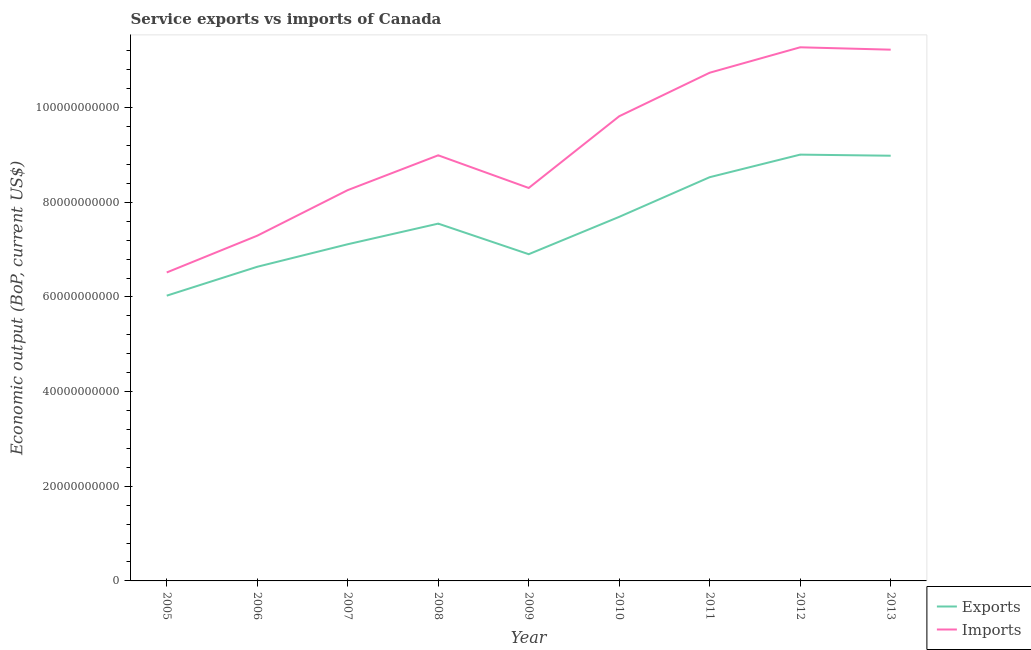Does the line corresponding to amount of service imports intersect with the line corresponding to amount of service exports?
Your answer should be compact. No. Is the number of lines equal to the number of legend labels?
Make the answer very short. Yes. What is the amount of service imports in 2007?
Keep it short and to the point. 8.26e+1. Across all years, what is the maximum amount of service exports?
Your answer should be compact. 9.01e+1. Across all years, what is the minimum amount of service exports?
Make the answer very short. 6.03e+1. In which year was the amount of service imports minimum?
Provide a succinct answer. 2005. What is the total amount of service exports in the graph?
Your response must be concise. 6.84e+11. What is the difference between the amount of service exports in 2011 and that in 2012?
Provide a short and direct response. -4.77e+09. What is the difference between the amount of service imports in 2008 and the amount of service exports in 2005?
Keep it short and to the point. 2.97e+1. What is the average amount of service imports per year?
Provide a succinct answer. 9.16e+1. In the year 2013, what is the difference between the amount of service exports and amount of service imports?
Your response must be concise. -2.24e+1. In how many years, is the amount of service imports greater than 36000000000 US$?
Your answer should be compact. 9. What is the ratio of the amount of service exports in 2010 to that in 2011?
Keep it short and to the point. 0.9. Is the difference between the amount of service imports in 2005 and 2010 greater than the difference between the amount of service exports in 2005 and 2010?
Your response must be concise. No. What is the difference between the highest and the second highest amount of service imports?
Give a very brief answer. 5.01e+08. What is the difference between the highest and the lowest amount of service imports?
Give a very brief answer. 4.76e+1. Is the amount of service exports strictly greater than the amount of service imports over the years?
Provide a short and direct response. No. How many lines are there?
Provide a succinct answer. 2. How many years are there in the graph?
Provide a succinct answer. 9. Does the graph contain any zero values?
Your response must be concise. No. What is the title of the graph?
Keep it short and to the point. Service exports vs imports of Canada. What is the label or title of the X-axis?
Your answer should be very brief. Year. What is the label or title of the Y-axis?
Keep it short and to the point. Economic output (BoP, current US$). What is the Economic output (BoP, current US$) of Exports in 2005?
Your answer should be very brief. 6.03e+1. What is the Economic output (BoP, current US$) in Imports in 2005?
Your response must be concise. 6.52e+1. What is the Economic output (BoP, current US$) of Exports in 2006?
Provide a short and direct response. 6.64e+1. What is the Economic output (BoP, current US$) of Imports in 2006?
Give a very brief answer. 7.29e+1. What is the Economic output (BoP, current US$) of Exports in 2007?
Keep it short and to the point. 7.11e+1. What is the Economic output (BoP, current US$) in Imports in 2007?
Your response must be concise. 8.26e+1. What is the Economic output (BoP, current US$) in Exports in 2008?
Your answer should be compact. 7.55e+1. What is the Economic output (BoP, current US$) of Imports in 2008?
Ensure brevity in your answer.  8.99e+1. What is the Economic output (BoP, current US$) of Exports in 2009?
Ensure brevity in your answer.  6.90e+1. What is the Economic output (BoP, current US$) in Imports in 2009?
Make the answer very short. 8.30e+1. What is the Economic output (BoP, current US$) of Exports in 2010?
Give a very brief answer. 7.69e+1. What is the Economic output (BoP, current US$) in Imports in 2010?
Your response must be concise. 9.82e+1. What is the Economic output (BoP, current US$) of Exports in 2011?
Offer a very short reply. 8.53e+1. What is the Economic output (BoP, current US$) of Imports in 2011?
Keep it short and to the point. 1.07e+11. What is the Economic output (BoP, current US$) of Exports in 2012?
Ensure brevity in your answer.  9.01e+1. What is the Economic output (BoP, current US$) of Imports in 2012?
Your answer should be compact. 1.13e+11. What is the Economic output (BoP, current US$) of Exports in 2013?
Give a very brief answer. 8.98e+1. What is the Economic output (BoP, current US$) in Imports in 2013?
Offer a very short reply. 1.12e+11. Across all years, what is the maximum Economic output (BoP, current US$) of Exports?
Your answer should be very brief. 9.01e+1. Across all years, what is the maximum Economic output (BoP, current US$) in Imports?
Give a very brief answer. 1.13e+11. Across all years, what is the minimum Economic output (BoP, current US$) in Exports?
Your answer should be compact. 6.03e+1. Across all years, what is the minimum Economic output (BoP, current US$) of Imports?
Keep it short and to the point. 6.52e+1. What is the total Economic output (BoP, current US$) in Exports in the graph?
Your answer should be compact. 6.84e+11. What is the total Economic output (BoP, current US$) of Imports in the graph?
Your answer should be compact. 8.24e+11. What is the difference between the Economic output (BoP, current US$) of Exports in 2005 and that in 2006?
Ensure brevity in your answer.  -6.10e+09. What is the difference between the Economic output (BoP, current US$) of Imports in 2005 and that in 2006?
Offer a very short reply. -7.77e+09. What is the difference between the Economic output (BoP, current US$) in Exports in 2005 and that in 2007?
Offer a very short reply. -1.09e+1. What is the difference between the Economic output (BoP, current US$) in Imports in 2005 and that in 2007?
Your response must be concise. -1.74e+1. What is the difference between the Economic output (BoP, current US$) of Exports in 2005 and that in 2008?
Give a very brief answer. -1.52e+1. What is the difference between the Economic output (BoP, current US$) of Imports in 2005 and that in 2008?
Give a very brief answer. -2.48e+1. What is the difference between the Economic output (BoP, current US$) in Exports in 2005 and that in 2009?
Your answer should be very brief. -8.76e+09. What is the difference between the Economic output (BoP, current US$) of Imports in 2005 and that in 2009?
Provide a succinct answer. -1.79e+1. What is the difference between the Economic output (BoP, current US$) in Exports in 2005 and that in 2010?
Offer a very short reply. -1.67e+1. What is the difference between the Economic output (BoP, current US$) of Imports in 2005 and that in 2010?
Your answer should be compact. -3.30e+1. What is the difference between the Economic output (BoP, current US$) of Exports in 2005 and that in 2011?
Offer a very short reply. -2.50e+1. What is the difference between the Economic output (BoP, current US$) of Imports in 2005 and that in 2011?
Provide a short and direct response. -4.22e+1. What is the difference between the Economic output (BoP, current US$) in Exports in 2005 and that in 2012?
Give a very brief answer. -2.98e+1. What is the difference between the Economic output (BoP, current US$) of Imports in 2005 and that in 2012?
Provide a short and direct response. -4.76e+1. What is the difference between the Economic output (BoP, current US$) in Exports in 2005 and that in 2013?
Make the answer very short. -2.96e+1. What is the difference between the Economic output (BoP, current US$) of Imports in 2005 and that in 2013?
Provide a succinct answer. -4.71e+1. What is the difference between the Economic output (BoP, current US$) in Exports in 2006 and that in 2007?
Give a very brief answer. -4.76e+09. What is the difference between the Economic output (BoP, current US$) in Imports in 2006 and that in 2007?
Make the answer very short. -9.63e+09. What is the difference between the Economic output (BoP, current US$) in Exports in 2006 and that in 2008?
Offer a very short reply. -9.12e+09. What is the difference between the Economic output (BoP, current US$) of Imports in 2006 and that in 2008?
Provide a succinct answer. -1.70e+1. What is the difference between the Economic output (BoP, current US$) of Exports in 2006 and that in 2009?
Give a very brief answer. -2.66e+09. What is the difference between the Economic output (BoP, current US$) of Imports in 2006 and that in 2009?
Keep it short and to the point. -1.01e+1. What is the difference between the Economic output (BoP, current US$) in Exports in 2006 and that in 2010?
Make the answer very short. -1.05e+1. What is the difference between the Economic output (BoP, current US$) of Imports in 2006 and that in 2010?
Your answer should be compact. -2.52e+1. What is the difference between the Economic output (BoP, current US$) in Exports in 2006 and that in 2011?
Provide a succinct answer. -1.89e+1. What is the difference between the Economic output (BoP, current US$) in Imports in 2006 and that in 2011?
Your response must be concise. -3.44e+1. What is the difference between the Economic output (BoP, current US$) in Exports in 2006 and that in 2012?
Offer a terse response. -2.37e+1. What is the difference between the Economic output (BoP, current US$) in Imports in 2006 and that in 2012?
Give a very brief answer. -3.98e+1. What is the difference between the Economic output (BoP, current US$) of Exports in 2006 and that in 2013?
Your answer should be very brief. -2.35e+1. What is the difference between the Economic output (BoP, current US$) of Imports in 2006 and that in 2013?
Your answer should be compact. -3.93e+1. What is the difference between the Economic output (BoP, current US$) in Exports in 2007 and that in 2008?
Offer a very short reply. -4.36e+09. What is the difference between the Economic output (BoP, current US$) in Imports in 2007 and that in 2008?
Make the answer very short. -7.35e+09. What is the difference between the Economic output (BoP, current US$) in Exports in 2007 and that in 2009?
Your answer should be very brief. 2.10e+09. What is the difference between the Economic output (BoP, current US$) in Imports in 2007 and that in 2009?
Your response must be concise. -4.55e+08. What is the difference between the Economic output (BoP, current US$) of Exports in 2007 and that in 2010?
Your answer should be very brief. -5.79e+09. What is the difference between the Economic output (BoP, current US$) in Imports in 2007 and that in 2010?
Offer a very short reply. -1.56e+1. What is the difference between the Economic output (BoP, current US$) of Exports in 2007 and that in 2011?
Offer a terse response. -1.42e+1. What is the difference between the Economic output (BoP, current US$) of Imports in 2007 and that in 2011?
Offer a very short reply. -2.48e+1. What is the difference between the Economic output (BoP, current US$) in Exports in 2007 and that in 2012?
Make the answer very short. -1.89e+1. What is the difference between the Economic output (BoP, current US$) in Imports in 2007 and that in 2012?
Ensure brevity in your answer.  -3.02e+1. What is the difference between the Economic output (BoP, current US$) in Exports in 2007 and that in 2013?
Your response must be concise. -1.87e+1. What is the difference between the Economic output (BoP, current US$) in Imports in 2007 and that in 2013?
Your answer should be compact. -2.97e+1. What is the difference between the Economic output (BoP, current US$) of Exports in 2008 and that in 2009?
Keep it short and to the point. 6.46e+09. What is the difference between the Economic output (BoP, current US$) in Imports in 2008 and that in 2009?
Give a very brief answer. 6.90e+09. What is the difference between the Economic output (BoP, current US$) in Exports in 2008 and that in 2010?
Offer a terse response. -1.43e+09. What is the difference between the Economic output (BoP, current US$) in Imports in 2008 and that in 2010?
Give a very brief answer. -8.25e+09. What is the difference between the Economic output (BoP, current US$) of Exports in 2008 and that in 2011?
Ensure brevity in your answer.  -9.81e+09. What is the difference between the Economic output (BoP, current US$) of Imports in 2008 and that in 2011?
Your answer should be compact. -1.75e+1. What is the difference between the Economic output (BoP, current US$) of Exports in 2008 and that in 2012?
Ensure brevity in your answer.  -1.46e+1. What is the difference between the Economic output (BoP, current US$) of Imports in 2008 and that in 2012?
Make the answer very short. -2.28e+1. What is the difference between the Economic output (BoP, current US$) in Exports in 2008 and that in 2013?
Ensure brevity in your answer.  -1.43e+1. What is the difference between the Economic output (BoP, current US$) in Imports in 2008 and that in 2013?
Offer a terse response. -2.23e+1. What is the difference between the Economic output (BoP, current US$) of Exports in 2009 and that in 2010?
Your response must be concise. -7.89e+09. What is the difference between the Economic output (BoP, current US$) of Imports in 2009 and that in 2010?
Provide a short and direct response. -1.52e+1. What is the difference between the Economic output (BoP, current US$) of Exports in 2009 and that in 2011?
Give a very brief answer. -1.63e+1. What is the difference between the Economic output (BoP, current US$) of Imports in 2009 and that in 2011?
Provide a succinct answer. -2.44e+1. What is the difference between the Economic output (BoP, current US$) in Exports in 2009 and that in 2012?
Keep it short and to the point. -2.10e+1. What is the difference between the Economic output (BoP, current US$) of Imports in 2009 and that in 2012?
Provide a short and direct response. -2.97e+1. What is the difference between the Economic output (BoP, current US$) in Exports in 2009 and that in 2013?
Offer a terse response. -2.08e+1. What is the difference between the Economic output (BoP, current US$) in Imports in 2009 and that in 2013?
Provide a short and direct response. -2.92e+1. What is the difference between the Economic output (BoP, current US$) in Exports in 2010 and that in 2011?
Your response must be concise. -8.38e+09. What is the difference between the Economic output (BoP, current US$) of Imports in 2010 and that in 2011?
Keep it short and to the point. -9.20e+09. What is the difference between the Economic output (BoP, current US$) in Exports in 2010 and that in 2012?
Ensure brevity in your answer.  -1.32e+1. What is the difference between the Economic output (BoP, current US$) of Imports in 2010 and that in 2012?
Offer a terse response. -1.46e+1. What is the difference between the Economic output (BoP, current US$) in Exports in 2010 and that in 2013?
Provide a succinct answer. -1.29e+1. What is the difference between the Economic output (BoP, current US$) of Imports in 2010 and that in 2013?
Make the answer very short. -1.41e+1. What is the difference between the Economic output (BoP, current US$) in Exports in 2011 and that in 2012?
Offer a very short reply. -4.77e+09. What is the difference between the Economic output (BoP, current US$) in Imports in 2011 and that in 2012?
Provide a short and direct response. -5.37e+09. What is the difference between the Economic output (BoP, current US$) of Exports in 2011 and that in 2013?
Provide a short and direct response. -4.54e+09. What is the difference between the Economic output (BoP, current US$) in Imports in 2011 and that in 2013?
Ensure brevity in your answer.  -4.87e+09. What is the difference between the Economic output (BoP, current US$) in Exports in 2012 and that in 2013?
Provide a short and direct response. 2.33e+08. What is the difference between the Economic output (BoP, current US$) in Imports in 2012 and that in 2013?
Provide a short and direct response. 5.01e+08. What is the difference between the Economic output (BoP, current US$) in Exports in 2005 and the Economic output (BoP, current US$) in Imports in 2006?
Make the answer very short. -1.27e+1. What is the difference between the Economic output (BoP, current US$) of Exports in 2005 and the Economic output (BoP, current US$) of Imports in 2007?
Ensure brevity in your answer.  -2.23e+1. What is the difference between the Economic output (BoP, current US$) of Exports in 2005 and the Economic output (BoP, current US$) of Imports in 2008?
Offer a terse response. -2.97e+1. What is the difference between the Economic output (BoP, current US$) in Exports in 2005 and the Economic output (BoP, current US$) in Imports in 2009?
Offer a very short reply. -2.28e+1. What is the difference between the Economic output (BoP, current US$) in Exports in 2005 and the Economic output (BoP, current US$) in Imports in 2010?
Make the answer very short. -3.79e+1. What is the difference between the Economic output (BoP, current US$) of Exports in 2005 and the Economic output (BoP, current US$) of Imports in 2011?
Make the answer very short. -4.71e+1. What is the difference between the Economic output (BoP, current US$) in Exports in 2005 and the Economic output (BoP, current US$) in Imports in 2012?
Ensure brevity in your answer.  -5.25e+1. What is the difference between the Economic output (BoP, current US$) of Exports in 2005 and the Economic output (BoP, current US$) of Imports in 2013?
Offer a terse response. -5.20e+1. What is the difference between the Economic output (BoP, current US$) of Exports in 2006 and the Economic output (BoP, current US$) of Imports in 2007?
Your response must be concise. -1.62e+1. What is the difference between the Economic output (BoP, current US$) in Exports in 2006 and the Economic output (BoP, current US$) in Imports in 2008?
Keep it short and to the point. -2.36e+1. What is the difference between the Economic output (BoP, current US$) in Exports in 2006 and the Economic output (BoP, current US$) in Imports in 2009?
Your answer should be very brief. -1.67e+1. What is the difference between the Economic output (BoP, current US$) in Exports in 2006 and the Economic output (BoP, current US$) in Imports in 2010?
Your answer should be very brief. -3.18e+1. What is the difference between the Economic output (BoP, current US$) of Exports in 2006 and the Economic output (BoP, current US$) of Imports in 2011?
Give a very brief answer. -4.10e+1. What is the difference between the Economic output (BoP, current US$) in Exports in 2006 and the Economic output (BoP, current US$) in Imports in 2012?
Make the answer very short. -4.64e+1. What is the difference between the Economic output (BoP, current US$) in Exports in 2006 and the Economic output (BoP, current US$) in Imports in 2013?
Your response must be concise. -4.59e+1. What is the difference between the Economic output (BoP, current US$) of Exports in 2007 and the Economic output (BoP, current US$) of Imports in 2008?
Keep it short and to the point. -1.88e+1. What is the difference between the Economic output (BoP, current US$) of Exports in 2007 and the Economic output (BoP, current US$) of Imports in 2009?
Give a very brief answer. -1.19e+1. What is the difference between the Economic output (BoP, current US$) in Exports in 2007 and the Economic output (BoP, current US$) in Imports in 2010?
Keep it short and to the point. -2.70e+1. What is the difference between the Economic output (BoP, current US$) in Exports in 2007 and the Economic output (BoP, current US$) in Imports in 2011?
Offer a terse response. -3.62e+1. What is the difference between the Economic output (BoP, current US$) in Exports in 2007 and the Economic output (BoP, current US$) in Imports in 2012?
Make the answer very short. -4.16e+1. What is the difference between the Economic output (BoP, current US$) in Exports in 2007 and the Economic output (BoP, current US$) in Imports in 2013?
Your response must be concise. -4.11e+1. What is the difference between the Economic output (BoP, current US$) in Exports in 2008 and the Economic output (BoP, current US$) in Imports in 2009?
Ensure brevity in your answer.  -7.53e+09. What is the difference between the Economic output (BoP, current US$) of Exports in 2008 and the Economic output (BoP, current US$) of Imports in 2010?
Make the answer very short. -2.27e+1. What is the difference between the Economic output (BoP, current US$) in Exports in 2008 and the Economic output (BoP, current US$) in Imports in 2011?
Give a very brief answer. -3.19e+1. What is the difference between the Economic output (BoP, current US$) of Exports in 2008 and the Economic output (BoP, current US$) of Imports in 2012?
Your response must be concise. -3.73e+1. What is the difference between the Economic output (BoP, current US$) of Exports in 2008 and the Economic output (BoP, current US$) of Imports in 2013?
Your response must be concise. -3.68e+1. What is the difference between the Economic output (BoP, current US$) in Exports in 2009 and the Economic output (BoP, current US$) in Imports in 2010?
Provide a succinct answer. -2.91e+1. What is the difference between the Economic output (BoP, current US$) of Exports in 2009 and the Economic output (BoP, current US$) of Imports in 2011?
Provide a succinct answer. -3.83e+1. What is the difference between the Economic output (BoP, current US$) of Exports in 2009 and the Economic output (BoP, current US$) of Imports in 2012?
Give a very brief answer. -4.37e+1. What is the difference between the Economic output (BoP, current US$) of Exports in 2009 and the Economic output (BoP, current US$) of Imports in 2013?
Your answer should be very brief. -4.32e+1. What is the difference between the Economic output (BoP, current US$) of Exports in 2010 and the Economic output (BoP, current US$) of Imports in 2011?
Your answer should be very brief. -3.05e+1. What is the difference between the Economic output (BoP, current US$) in Exports in 2010 and the Economic output (BoP, current US$) in Imports in 2012?
Make the answer very short. -3.58e+1. What is the difference between the Economic output (BoP, current US$) in Exports in 2010 and the Economic output (BoP, current US$) in Imports in 2013?
Offer a terse response. -3.53e+1. What is the difference between the Economic output (BoP, current US$) in Exports in 2011 and the Economic output (BoP, current US$) in Imports in 2012?
Offer a terse response. -2.74e+1. What is the difference between the Economic output (BoP, current US$) of Exports in 2011 and the Economic output (BoP, current US$) of Imports in 2013?
Ensure brevity in your answer.  -2.69e+1. What is the difference between the Economic output (BoP, current US$) in Exports in 2012 and the Economic output (BoP, current US$) in Imports in 2013?
Your answer should be compact. -2.22e+1. What is the average Economic output (BoP, current US$) of Exports per year?
Provide a short and direct response. 7.61e+1. What is the average Economic output (BoP, current US$) of Imports per year?
Your answer should be compact. 9.16e+1. In the year 2005, what is the difference between the Economic output (BoP, current US$) in Exports and Economic output (BoP, current US$) in Imports?
Offer a very short reply. -4.90e+09. In the year 2006, what is the difference between the Economic output (BoP, current US$) in Exports and Economic output (BoP, current US$) in Imports?
Ensure brevity in your answer.  -6.57e+09. In the year 2007, what is the difference between the Economic output (BoP, current US$) of Exports and Economic output (BoP, current US$) of Imports?
Offer a very short reply. -1.14e+1. In the year 2008, what is the difference between the Economic output (BoP, current US$) of Exports and Economic output (BoP, current US$) of Imports?
Provide a succinct answer. -1.44e+1. In the year 2009, what is the difference between the Economic output (BoP, current US$) in Exports and Economic output (BoP, current US$) in Imports?
Make the answer very short. -1.40e+1. In the year 2010, what is the difference between the Economic output (BoP, current US$) in Exports and Economic output (BoP, current US$) in Imports?
Keep it short and to the point. -2.13e+1. In the year 2011, what is the difference between the Economic output (BoP, current US$) of Exports and Economic output (BoP, current US$) of Imports?
Your answer should be very brief. -2.21e+1. In the year 2012, what is the difference between the Economic output (BoP, current US$) in Exports and Economic output (BoP, current US$) in Imports?
Provide a succinct answer. -2.27e+1. In the year 2013, what is the difference between the Economic output (BoP, current US$) in Exports and Economic output (BoP, current US$) in Imports?
Your answer should be very brief. -2.24e+1. What is the ratio of the Economic output (BoP, current US$) of Exports in 2005 to that in 2006?
Your answer should be compact. 0.91. What is the ratio of the Economic output (BoP, current US$) of Imports in 2005 to that in 2006?
Provide a short and direct response. 0.89. What is the ratio of the Economic output (BoP, current US$) in Exports in 2005 to that in 2007?
Your response must be concise. 0.85. What is the ratio of the Economic output (BoP, current US$) in Imports in 2005 to that in 2007?
Your response must be concise. 0.79. What is the ratio of the Economic output (BoP, current US$) of Exports in 2005 to that in 2008?
Ensure brevity in your answer.  0.8. What is the ratio of the Economic output (BoP, current US$) in Imports in 2005 to that in 2008?
Give a very brief answer. 0.72. What is the ratio of the Economic output (BoP, current US$) of Exports in 2005 to that in 2009?
Give a very brief answer. 0.87. What is the ratio of the Economic output (BoP, current US$) of Imports in 2005 to that in 2009?
Ensure brevity in your answer.  0.79. What is the ratio of the Economic output (BoP, current US$) in Exports in 2005 to that in 2010?
Keep it short and to the point. 0.78. What is the ratio of the Economic output (BoP, current US$) in Imports in 2005 to that in 2010?
Ensure brevity in your answer.  0.66. What is the ratio of the Economic output (BoP, current US$) of Exports in 2005 to that in 2011?
Provide a short and direct response. 0.71. What is the ratio of the Economic output (BoP, current US$) of Imports in 2005 to that in 2011?
Provide a short and direct response. 0.61. What is the ratio of the Economic output (BoP, current US$) of Exports in 2005 to that in 2012?
Your answer should be very brief. 0.67. What is the ratio of the Economic output (BoP, current US$) of Imports in 2005 to that in 2012?
Your answer should be very brief. 0.58. What is the ratio of the Economic output (BoP, current US$) in Exports in 2005 to that in 2013?
Offer a terse response. 0.67. What is the ratio of the Economic output (BoP, current US$) in Imports in 2005 to that in 2013?
Offer a terse response. 0.58. What is the ratio of the Economic output (BoP, current US$) of Exports in 2006 to that in 2007?
Make the answer very short. 0.93. What is the ratio of the Economic output (BoP, current US$) in Imports in 2006 to that in 2007?
Your answer should be very brief. 0.88. What is the ratio of the Economic output (BoP, current US$) of Exports in 2006 to that in 2008?
Your answer should be compact. 0.88. What is the ratio of the Economic output (BoP, current US$) of Imports in 2006 to that in 2008?
Ensure brevity in your answer.  0.81. What is the ratio of the Economic output (BoP, current US$) of Exports in 2006 to that in 2009?
Offer a terse response. 0.96. What is the ratio of the Economic output (BoP, current US$) in Imports in 2006 to that in 2009?
Offer a very short reply. 0.88. What is the ratio of the Economic output (BoP, current US$) in Exports in 2006 to that in 2010?
Give a very brief answer. 0.86. What is the ratio of the Economic output (BoP, current US$) in Imports in 2006 to that in 2010?
Provide a succinct answer. 0.74. What is the ratio of the Economic output (BoP, current US$) in Exports in 2006 to that in 2011?
Ensure brevity in your answer.  0.78. What is the ratio of the Economic output (BoP, current US$) of Imports in 2006 to that in 2011?
Ensure brevity in your answer.  0.68. What is the ratio of the Economic output (BoP, current US$) of Exports in 2006 to that in 2012?
Give a very brief answer. 0.74. What is the ratio of the Economic output (BoP, current US$) of Imports in 2006 to that in 2012?
Provide a succinct answer. 0.65. What is the ratio of the Economic output (BoP, current US$) of Exports in 2006 to that in 2013?
Give a very brief answer. 0.74. What is the ratio of the Economic output (BoP, current US$) of Imports in 2006 to that in 2013?
Your response must be concise. 0.65. What is the ratio of the Economic output (BoP, current US$) of Exports in 2007 to that in 2008?
Offer a very short reply. 0.94. What is the ratio of the Economic output (BoP, current US$) in Imports in 2007 to that in 2008?
Provide a short and direct response. 0.92. What is the ratio of the Economic output (BoP, current US$) of Exports in 2007 to that in 2009?
Your answer should be compact. 1.03. What is the ratio of the Economic output (BoP, current US$) of Imports in 2007 to that in 2009?
Provide a succinct answer. 0.99. What is the ratio of the Economic output (BoP, current US$) of Exports in 2007 to that in 2010?
Ensure brevity in your answer.  0.92. What is the ratio of the Economic output (BoP, current US$) in Imports in 2007 to that in 2010?
Offer a very short reply. 0.84. What is the ratio of the Economic output (BoP, current US$) in Exports in 2007 to that in 2011?
Your answer should be compact. 0.83. What is the ratio of the Economic output (BoP, current US$) of Imports in 2007 to that in 2011?
Provide a succinct answer. 0.77. What is the ratio of the Economic output (BoP, current US$) of Exports in 2007 to that in 2012?
Provide a short and direct response. 0.79. What is the ratio of the Economic output (BoP, current US$) in Imports in 2007 to that in 2012?
Make the answer very short. 0.73. What is the ratio of the Economic output (BoP, current US$) of Exports in 2007 to that in 2013?
Provide a short and direct response. 0.79. What is the ratio of the Economic output (BoP, current US$) in Imports in 2007 to that in 2013?
Keep it short and to the point. 0.74. What is the ratio of the Economic output (BoP, current US$) in Exports in 2008 to that in 2009?
Your answer should be very brief. 1.09. What is the ratio of the Economic output (BoP, current US$) of Imports in 2008 to that in 2009?
Provide a short and direct response. 1.08. What is the ratio of the Economic output (BoP, current US$) in Exports in 2008 to that in 2010?
Your answer should be very brief. 0.98. What is the ratio of the Economic output (BoP, current US$) of Imports in 2008 to that in 2010?
Provide a short and direct response. 0.92. What is the ratio of the Economic output (BoP, current US$) in Exports in 2008 to that in 2011?
Your response must be concise. 0.89. What is the ratio of the Economic output (BoP, current US$) in Imports in 2008 to that in 2011?
Provide a short and direct response. 0.84. What is the ratio of the Economic output (BoP, current US$) of Exports in 2008 to that in 2012?
Ensure brevity in your answer.  0.84. What is the ratio of the Economic output (BoP, current US$) of Imports in 2008 to that in 2012?
Give a very brief answer. 0.8. What is the ratio of the Economic output (BoP, current US$) of Exports in 2008 to that in 2013?
Offer a terse response. 0.84. What is the ratio of the Economic output (BoP, current US$) of Imports in 2008 to that in 2013?
Provide a succinct answer. 0.8. What is the ratio of the Economic output (BoP, current US$) in Exports in 2009 to that in 2010?
Offer a very short reply. 0.9. What is the ratio of the Economic output (BoP, current US$) of Imports in 2009 to that in 2010?
Make the answer very short. 0.85. What is the ratio of the Economic output (BoP, current US$) in Exports in 2009 to that in 2011?
Keep it short and to the point. 0.81. What is the ratio of the Economic output (BoP, current US$) of Imports in 2009 to that in 2011?
Your response must be concise. 0.77. What is the ratio of the Economic output (BoP, current US$) in Exports in 2009 to that in 2012?
Your answer should be compact. 0.77. What is the ratio of the Economic output (BoP, current US$) in Imports in 2009 to that in 2012?
Your answer should be very brief. 0.74. What is the ratio of the Economic output (BoP, current US$) of Exports in 2009 to that in 2013?
Keep it short and to the point. 0.77. What is the ratio of the Economic output (BoP, current US$) in Imports in 2009 to that in 2013?
Your answer should be very brief. 0.74. What is the ratio of the Economic output (BoP, current US$) in Exports in 2010 to that in 2011?
Your response must be concise. 0.9. What is the ratio of the Economic output (BoP, current US$) in Imports in 2010 to that in 2011?
Provide a succinct answer. 0.91. What is the ratio of the Economic output (BoP, current US$) of Exports in 2010 to that in 2012?
Make the answer very short. 0.85. What is the ratio of the Economic output (BoP, current US$) of Imports in 2010 to that in 2012?
Give a very brief answer. 0.87. What is the ratio of the Economic output (BoP, current US$) in Exports in 2010 to that in 2013?
Ensure brevity in your answer.  0.86. What is the ratio of the Economic output (BoP, current US$) of Imports in 2010 to that in 2013?
Ensure brevity in your answer.  0.87. What is the ratio of the Economic output (BoP, current US$) of Exports in 2011 to that in 2012?
Keep it short and to the point. 0.95. What is the ratio of the Economic output (BoP, current US$) in Imports in 2011 to that in 2012?
Offer a very short reply. 0.95. What is the ratio of the Economic output (BoP, current US$) in Exports in 2011 to that in 2013?
Your answer should be compact. 0.95. What is the ratio of the Economic output (BoP, current US$) in Imports in 2011 to that in 2013?
Your answer should be very brief. 0.96. What is the ratio of the Economic output (BoP, current US$) of Exports in 2012 to that in 2013?
Provide a short and direct response. 1. What is the ratio of the Economic output (BoP, current US$) in Imports in 2012 to that in 2013?
Provide a short and direct response. 1. What is the difference between the highest and the second highest Economic output (BoP, current US$) in Exports?
Your response must be concise. 2.33e+08. What is the difference between the highest and the second highest Economic output (BoP, current US$) of Imports?
Provide a short and direct response. 5.01e+08. What is the difference between the highest and the lowest Economic output (BoP, current US$) in Exports?
Ensure brevity in your answer.  2.98e+1. What is the difference between the highest and the lowest Economic output (BoP, current US$) of Imports?
Your answer should be compact. 4.76e+1. 